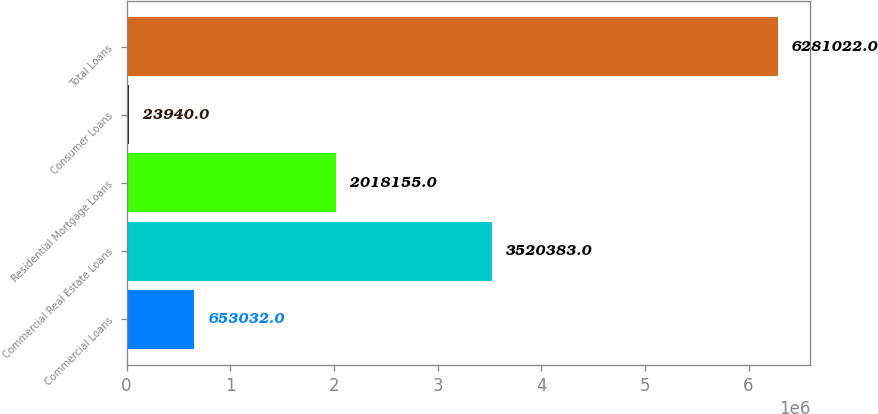<chart> <loc_0><loc_0><loc_500><loc_500><bar_chart><fcel>Commercial Loans<fcel>Commercial Real Estate Loans<fcel>Residential Mortgage Loans<fcel>Consumer Loans<fcel>Total Loans<nl><fcel>653032<fcel>3.52038e+06<fcel>2.01816e+06<fcel>23940<fcel>6.28102e+06<nl></chart> 